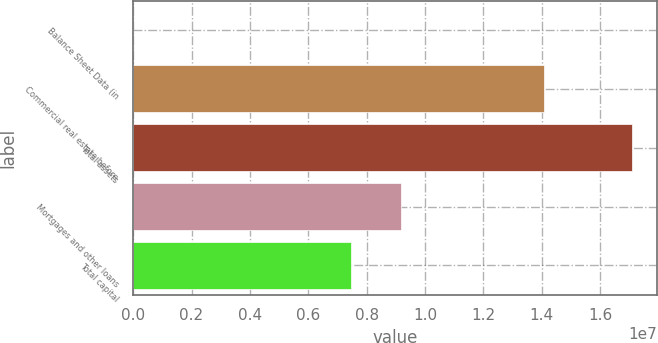<chart> <loc_0><loc_0><loc_500><loc_500><bar_chart><fcel>Balance Sheet Data (in<fcel>Commercial real estate before<fcel>Total assets<fcel>Mortgages and other loans<fcel>Total capital<nl><fcel>2014<fcel>1.40691e+07<fcel>1.70966e+07<fcel>9.16867e+06<fcel>7.45922e+06<nl></chart> 